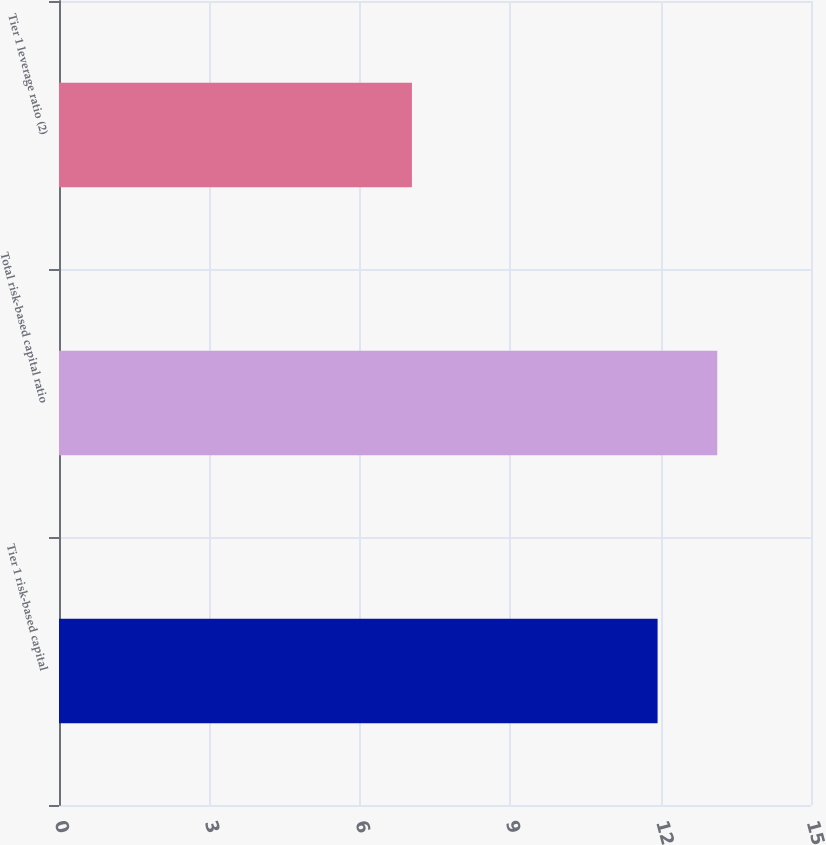Convert chart to OTSL. <chart><loc_0><loc_0><loc_500><loc_500><bar_chart><fcel>Tier 1 risk-based capital<fcel>Total risk-based capital ratio<fcel>Tier 1 leverage ratio (2)<nl><fcel>11.94<fcel>13.13<fcel>7.04<nl></chart> 